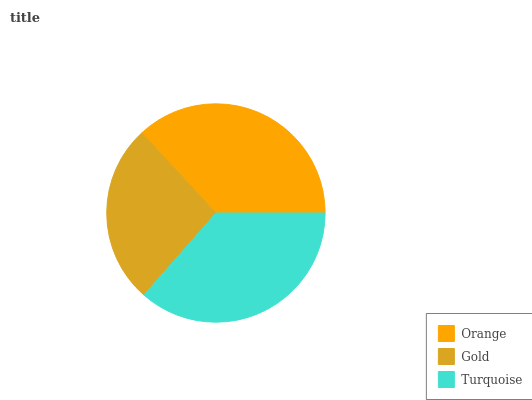Is Gold the minimum?
Answer yes or no. Yes. Is Orange the maximum?
Answer yes or no. Yes. Is Turquoise the minimum?
Answer yes or no. No. Is Turquoise the maximum?
Answer yes or no. No. Is Turquoise greater than Gold?
Answer yes or no. Yes. Is Gold less than Turquoise?
Answer yes or no. Yes. Is Gold greater than Turquoise?
Answer yes or no. No. Is Turquoise less than Gold?
Answer yes or no. No. Is Turquoise the high median?
Answer yes or no. Yes. Is Turquoise the low median?
Answer yes or no. Yes. Is Gold the high median?
Answer yes or no. No. Is Orange the low median?
Answer yes or no. No. 